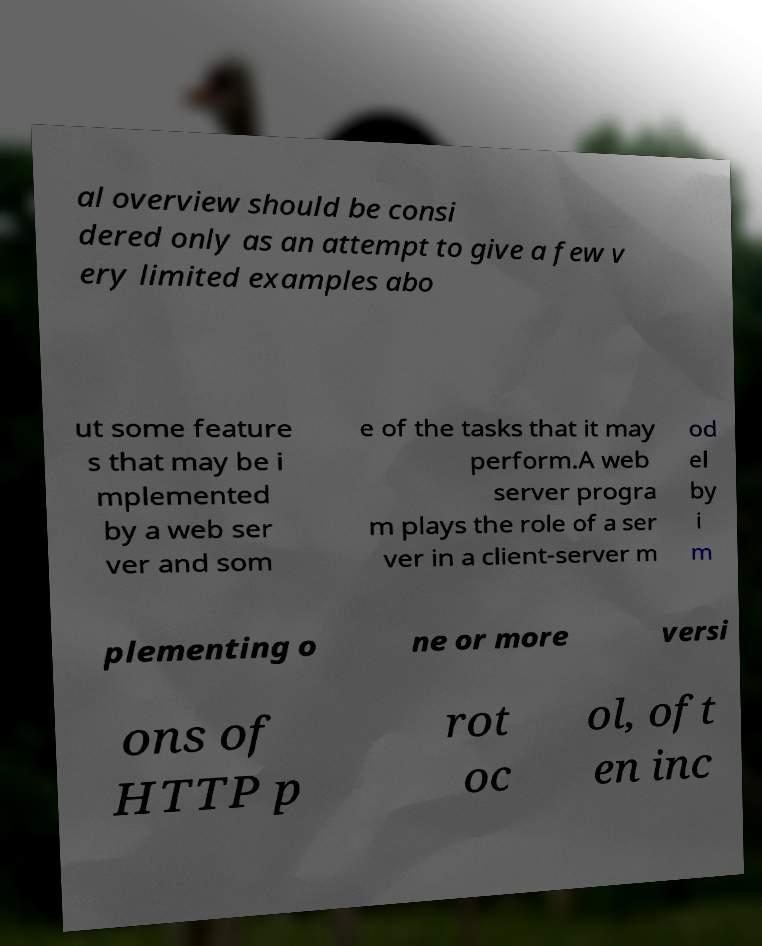Could you extract and type out the text from this image? al overview should be consi dered only as an attempt to give a few v ery limited examples abo ut some feature s that may be i mplemented by a web ser ver and som e of the tasks that it may perform.A web server progra m plays the role of a ser ver in a client-server m od el by i m plementing o ne or more versi ons of HTTP p rot oc ol, oft en inc 